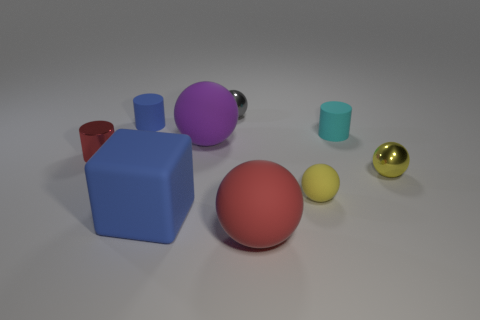Subtract all yellow metallic balls. How many balls are left? 4 Subtract all purple spheres. How many spheres are left? 4 Subtract all red spheres. Subtract all yellow cubes. How many spheres are left? 4 Subtract all cylinders. How many objects are left? 6 Add 7 small blue matte cylinders. How many small blue matte cylinders exist? 8 Subtract 0 gray cylinders. How many objects are left? 9 Subtract all tiny cyan matte objects. Subtract all big matte objects. How many objects are left? 5 Add 5 tiny cylinders. How many tiny cylinders are left? 8 